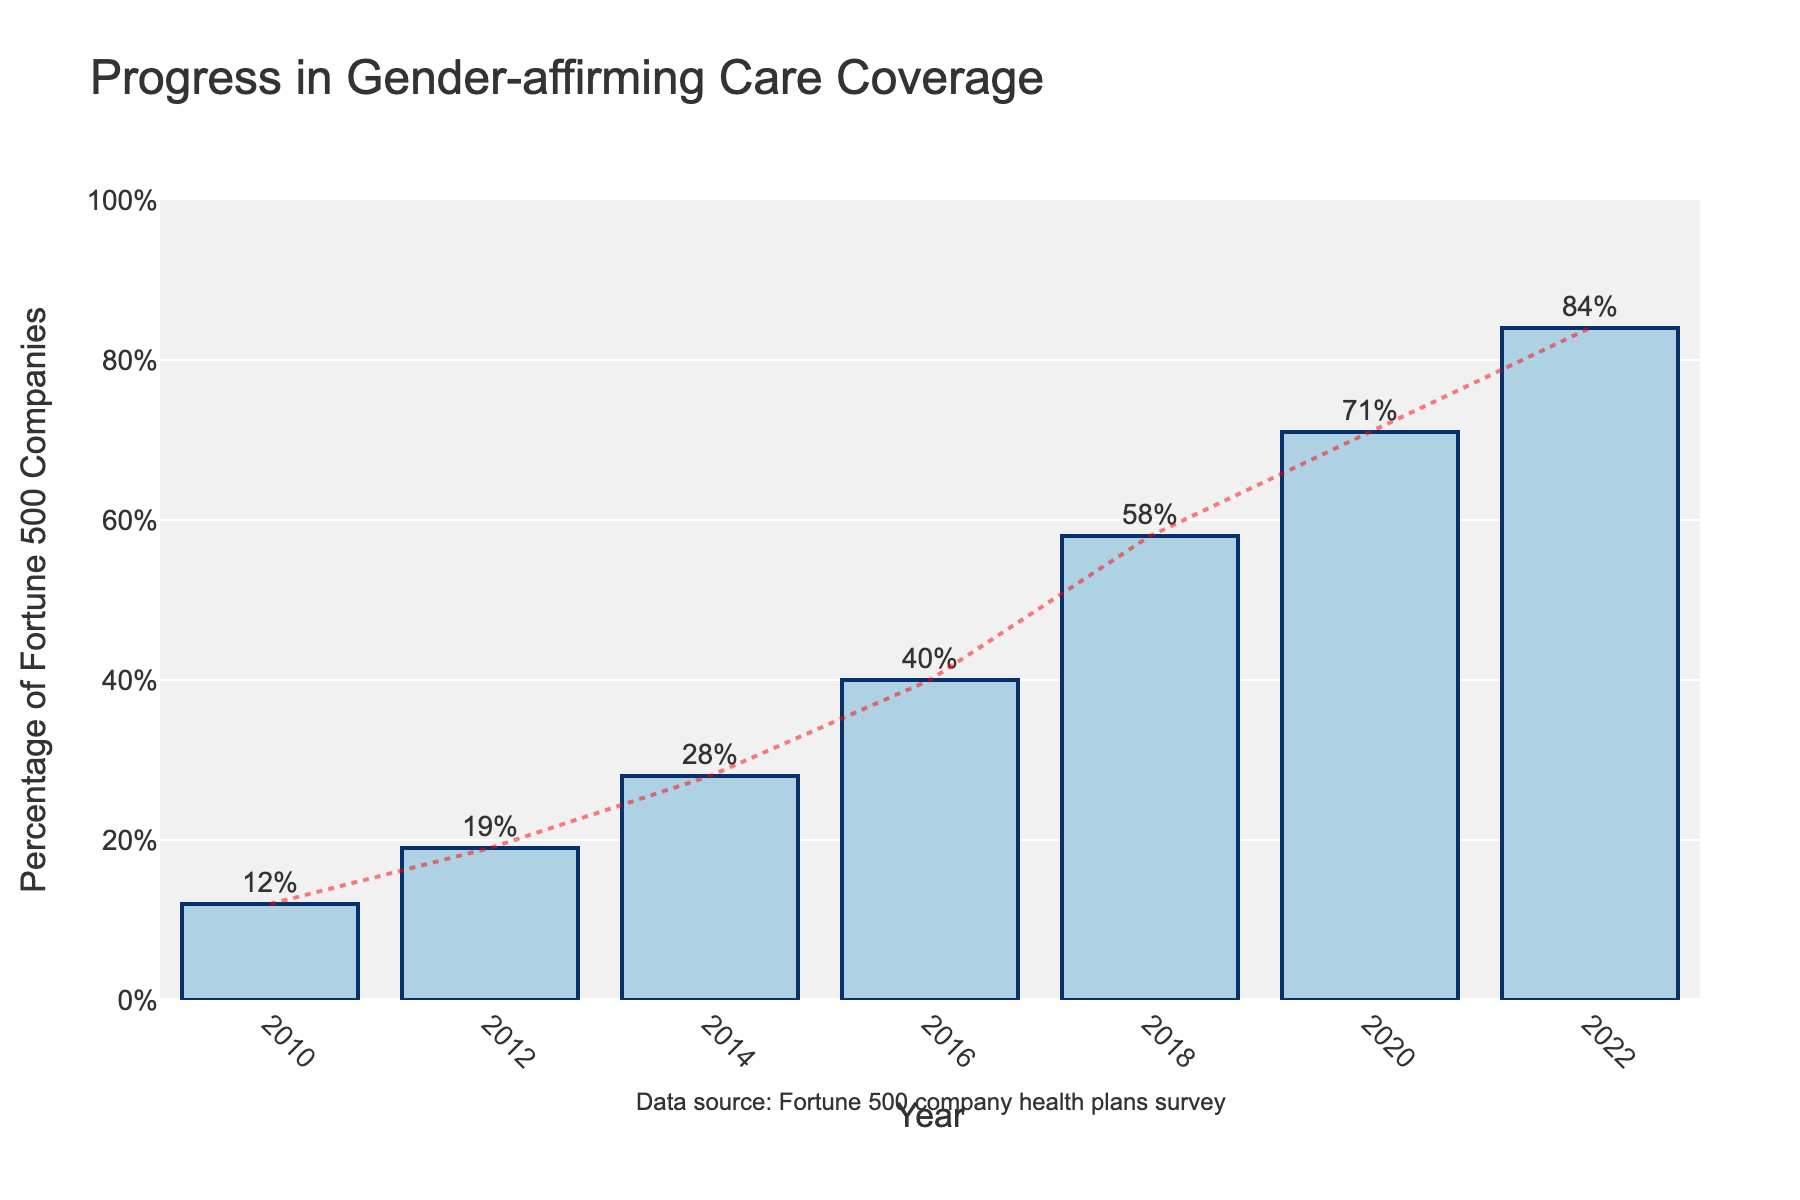what trend does the chart show over the years? The chart shows a positive upward trend in the percentage of Fortune 500 companies covering gender-affirming care, indicating significant growth from 2010 to 2022.
Answer: Upward trend What's the percentage increase in gender-affirming care coverage from 2010 to 2022? The percentage of Fortune 500 companies covering gender-affirming care increased from 12% in 2010 to 84% in 2022. To calculate the increase: 84% - 12% = 72%.
Answer: 72% Which year shows the highest coverage percentage? By examining the heights of the bars, the year 2022 shows the highest coverage percentage at 84%.
Answer: 2022 How does the coverage percentage in 2020 compare to 2016? The coverage percentage in 2020 is 71%, and in 2016 it is 40%. 71% is greater than 40%.
Answer: 71% > 40% What is the average percentage coverage for all the years shown? Add the percentages (12% + 19% + 28% + 40% + 58% + 71% + 84%) which equals to 312%. Then, divide by the number of years (7), giving (312% / 7) ≈ 44.6%.
Answer: 44.6% By how much did the coverage percentage increase from 2016 to 2018? The percentage increased from 40% in 2016 to 58% in 2018. The increase is 58% - 40% = 18%.
Answer: 18% What visual element is used to indicate the trend over time? The trend over time is indicated by a dotted line overlaying the bar chart.
Answer: Dotted line Between which two consecutive years was the largest percentage increase observed? Observe the differences between consecutive years: (19%-12%=7%), (28%-19%=9%), (40%-28%=12%), (58%-40%=18%), (71%-58%=13%), (84%-71%=13%). The largest increase is between 2016 and 2018, which is 18%.
Answer: 2016 and 2018 What does the tallest bar in the chart represent? The tallest bar represents the year 2022, with a coverage percentage of 84% for gender-affirming care.
Answer: 2022 with 84% 